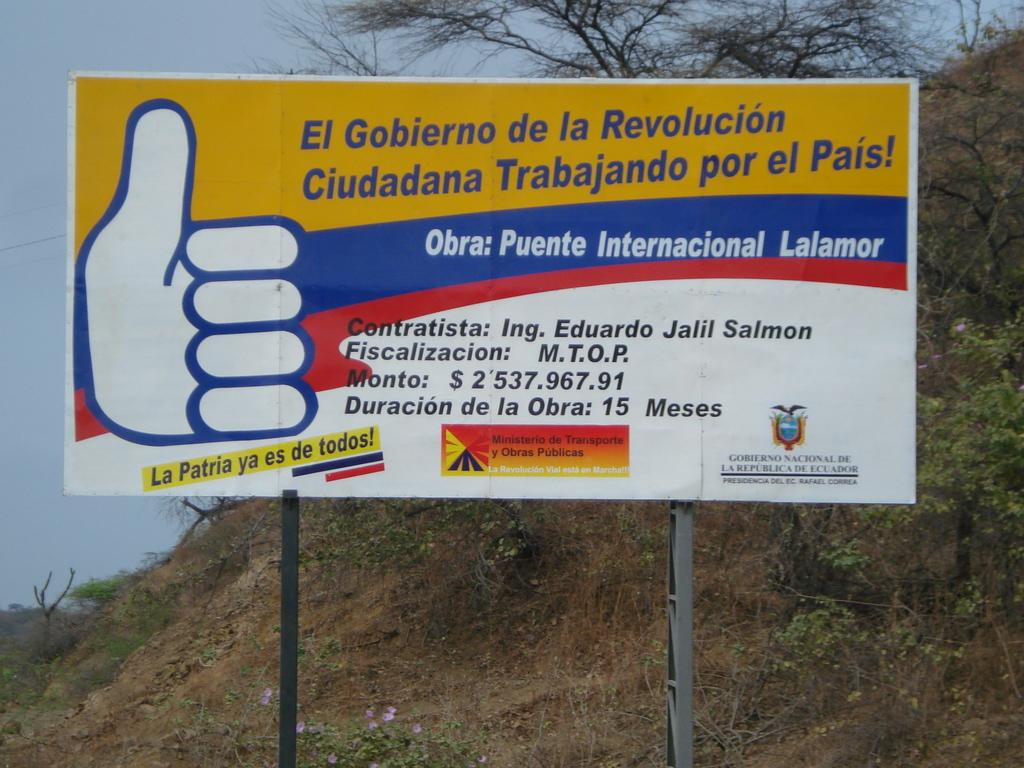<image>
Render a clear and concise summary of the photo. A large billboard has a thumbs up and says Obro: Puente Internacional Lalamor. 